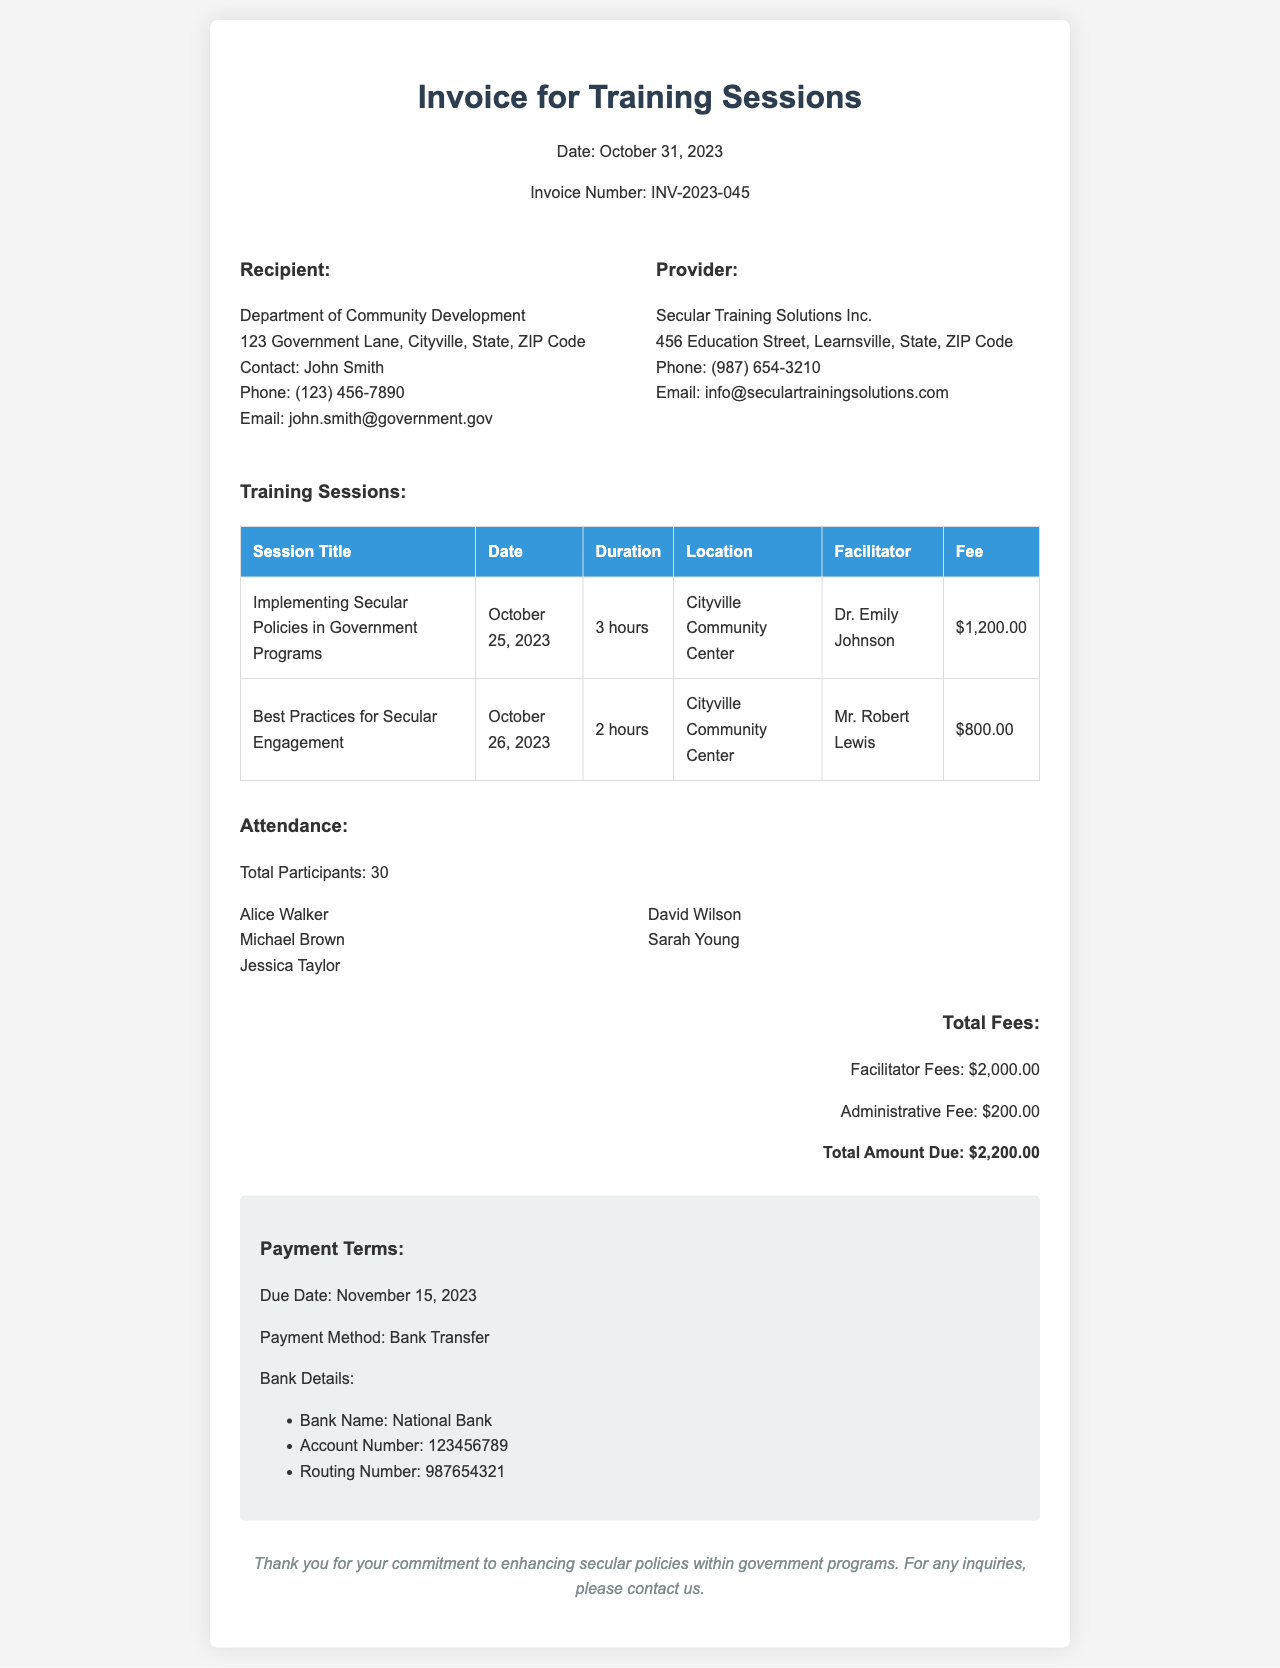What is the invoice number? The invoice number is listed in the document under the header section.
Answer: INV-2023-045 Who is the contact person for the recipient? The contact person for the recipient can be found in the recipient details section of the document.
Answer: John Smith What is the total amount due? The total amount due is explicitly stated in the total fees section of the document.
Answer: $2,200.00 Which training session had the highest fee? The session with the highest fee requires comparing the fees in the training sessions table.
Answer: Implementing Secular Policies in Government Programs How many total participants attended the sessions? The total number of participants is provided in the attendance section of the document.
Answer: 30 What is the due date for the payment? The due date for the payment is mentioned in the payment terms section of the document.
Answer: November 15, 2023 What is the administrative fee listed? The administrative fee can be found in the total fees section of the document.
Answer: $200.00 Who facilitated the session on Best Practices for Secular Engagement? The facilitator’s name for that specific session can be found in the training sessions table.
Answer: Mr. Robert Lewis What is the location of the training sessions? The location of the training sessions can be seen in the training sessions table.
Answer: Cityville Community Center 